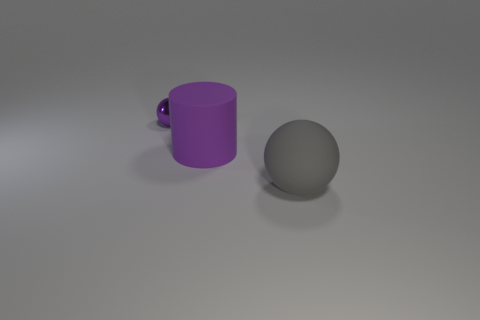There is a tiny purple thing that is the same shape as the gray object; what material is it?
Ensure brevity in your answer.  Metal. How many other matte spheres have the same size as the purple ball?
Ensure brevity in your answer.  0. What is the color of the object that is right of the small metal ball and left of the gray matte object?
Ensure brevity in your answer.  Purple. Is the number of matte spheres less than the number of small gray matte cubes?
Ensure brevity in your answer.  No. There is a tiny object; is its color the same as the rubber thing that is in front of the big purple rubber object?
Offer a very short reply. No. Are there an equal number of small purple metal objects behind the cylinder and large cylinders that are on the left side of the large gray rubber sphere?
Provide a short and direct response. Yes. How many other small objects have the same shape as the purple rubber thing?
Make the answer very short. 0. Are there any gray things?
Provide a short and direct response. Yes. Does the cylinder have the same material as the big object that is in front of the big purple object?
Give a very brief answer. Yes. There is a purple cylinder that is the same size as the gray object; what material is it?
Make the answer very short. Rubber. 